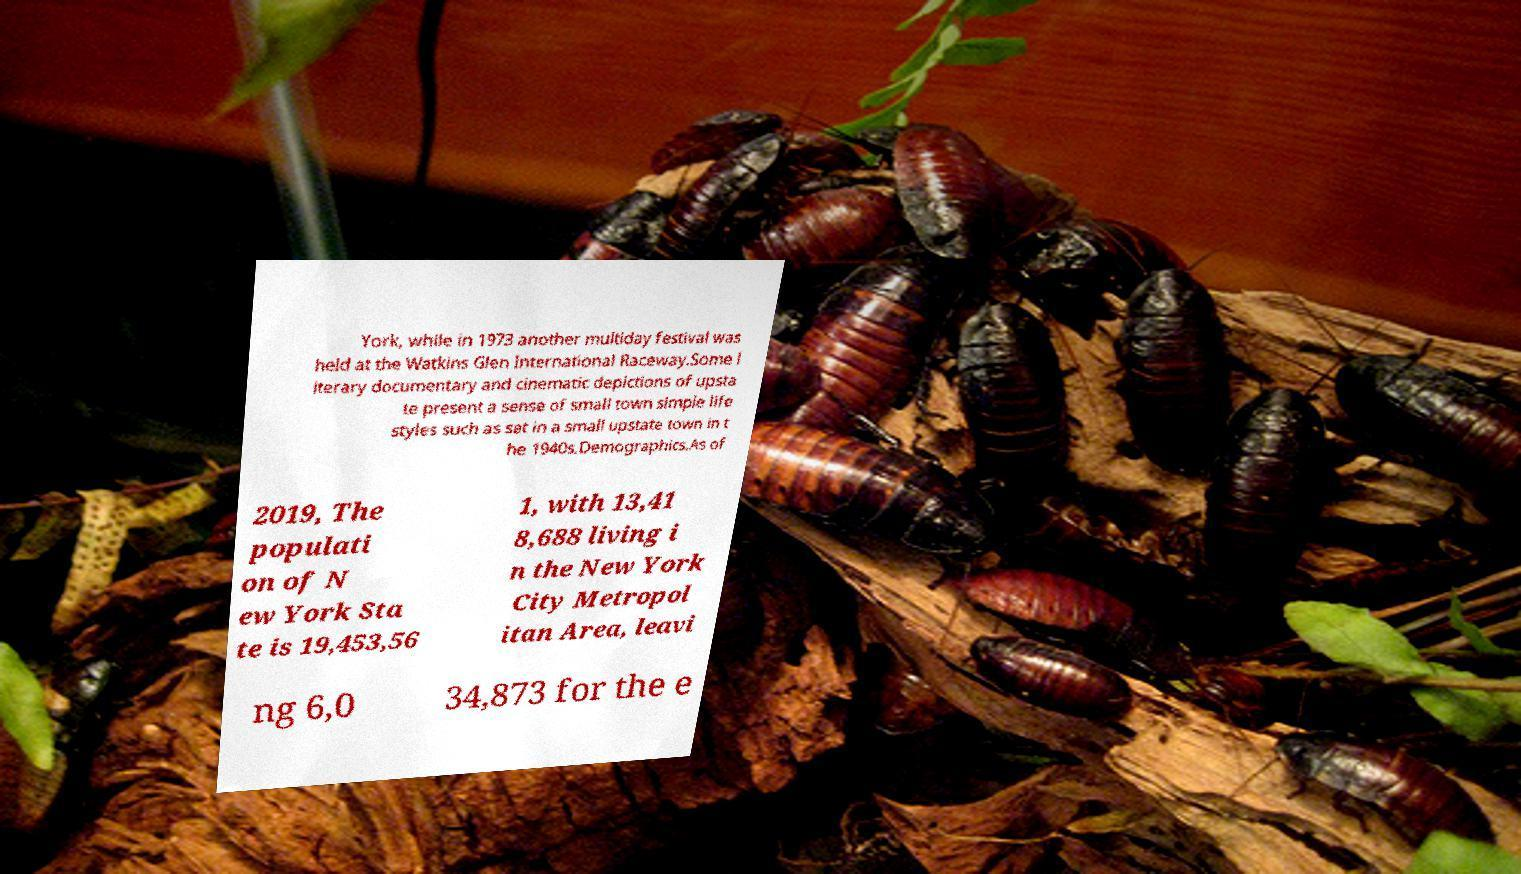What messages or text are displayed in this image? I need them in a readable, typed format. York, while in 1973 another multiday festival was held at the Watkins Glen International Raceway.Some l iterary documentary and cinematic depictions of upsta te present a sense of small town simple life styles such as set in a small upstate town in t he 1940s.Demographics.As of 2019, The populati on of N ew York Sta te is 19,453,56 1, with 13,41 8,688 living i n the New York City Metropol itan Area, leavi ng 6,0 34,873 for the e 